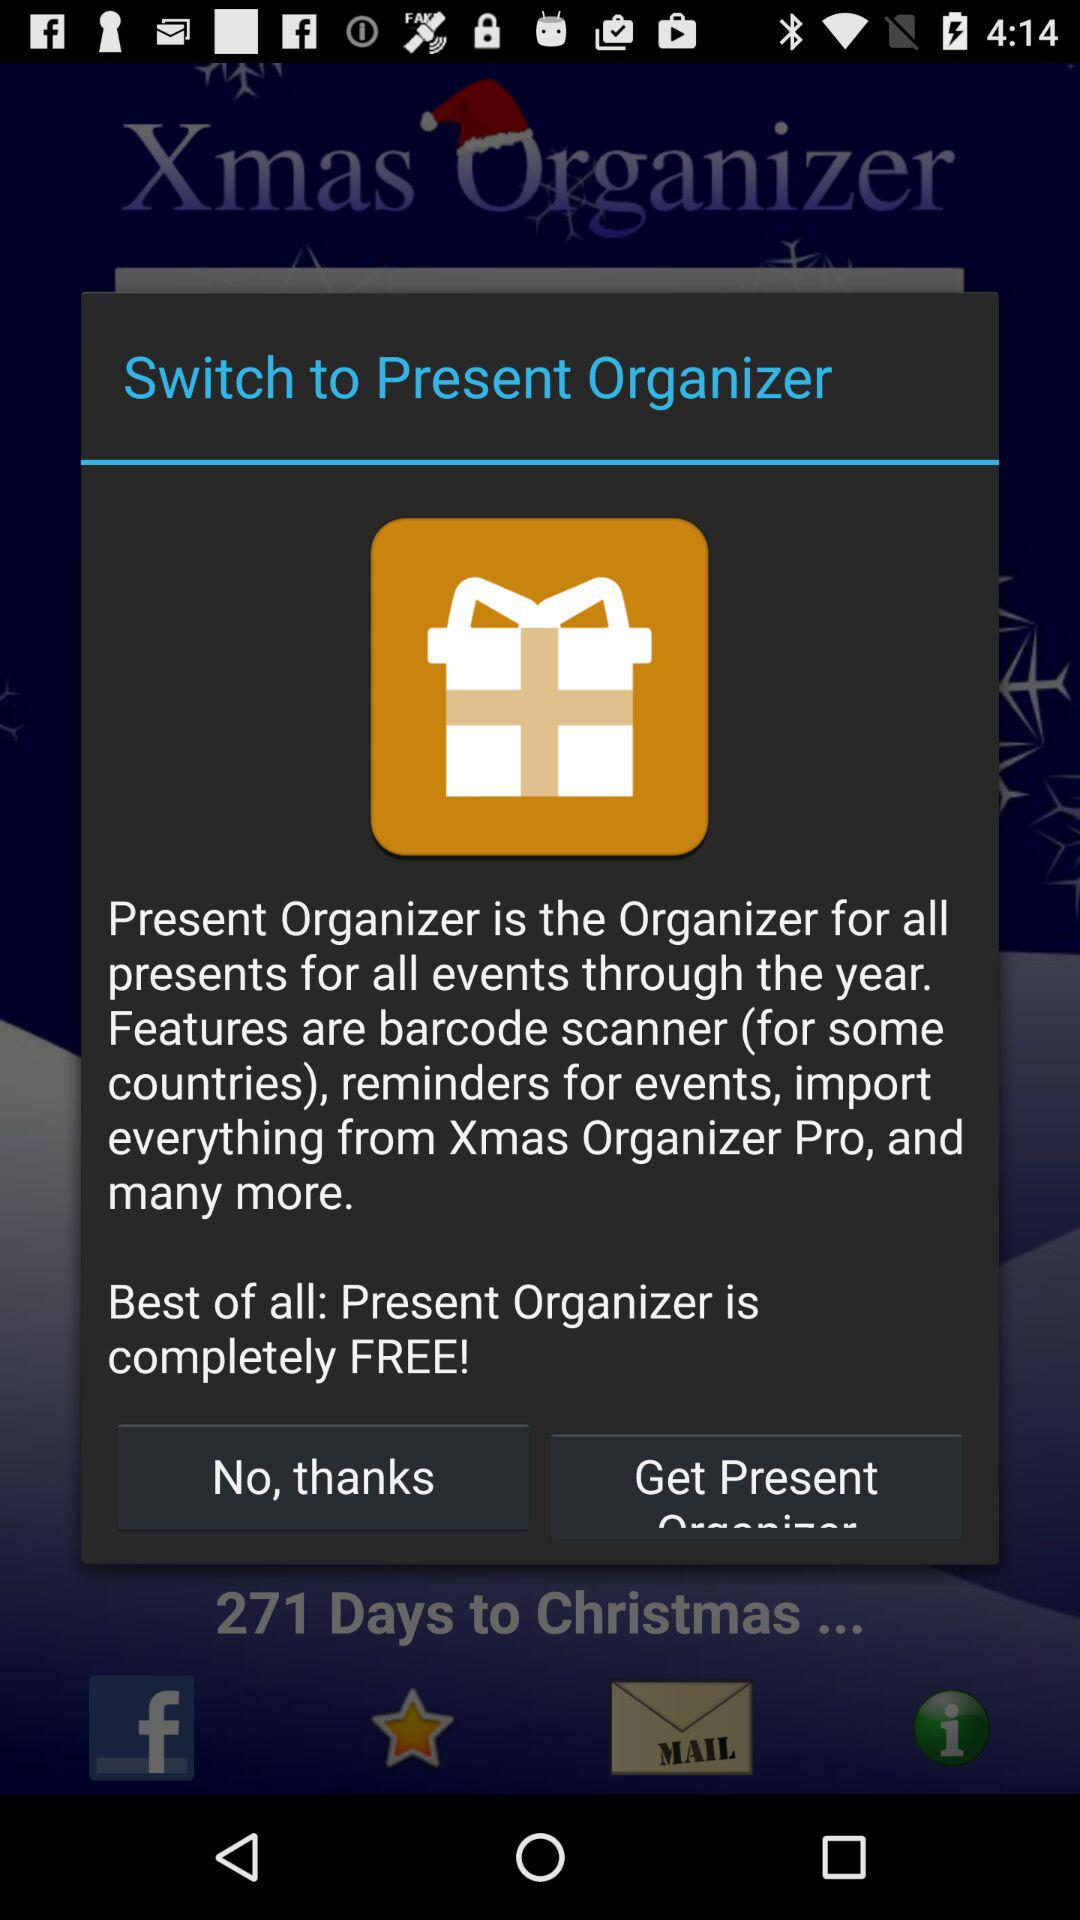How many starred items are there?
When the provided information is insufficient, respond with <no answer>. <no answer> 